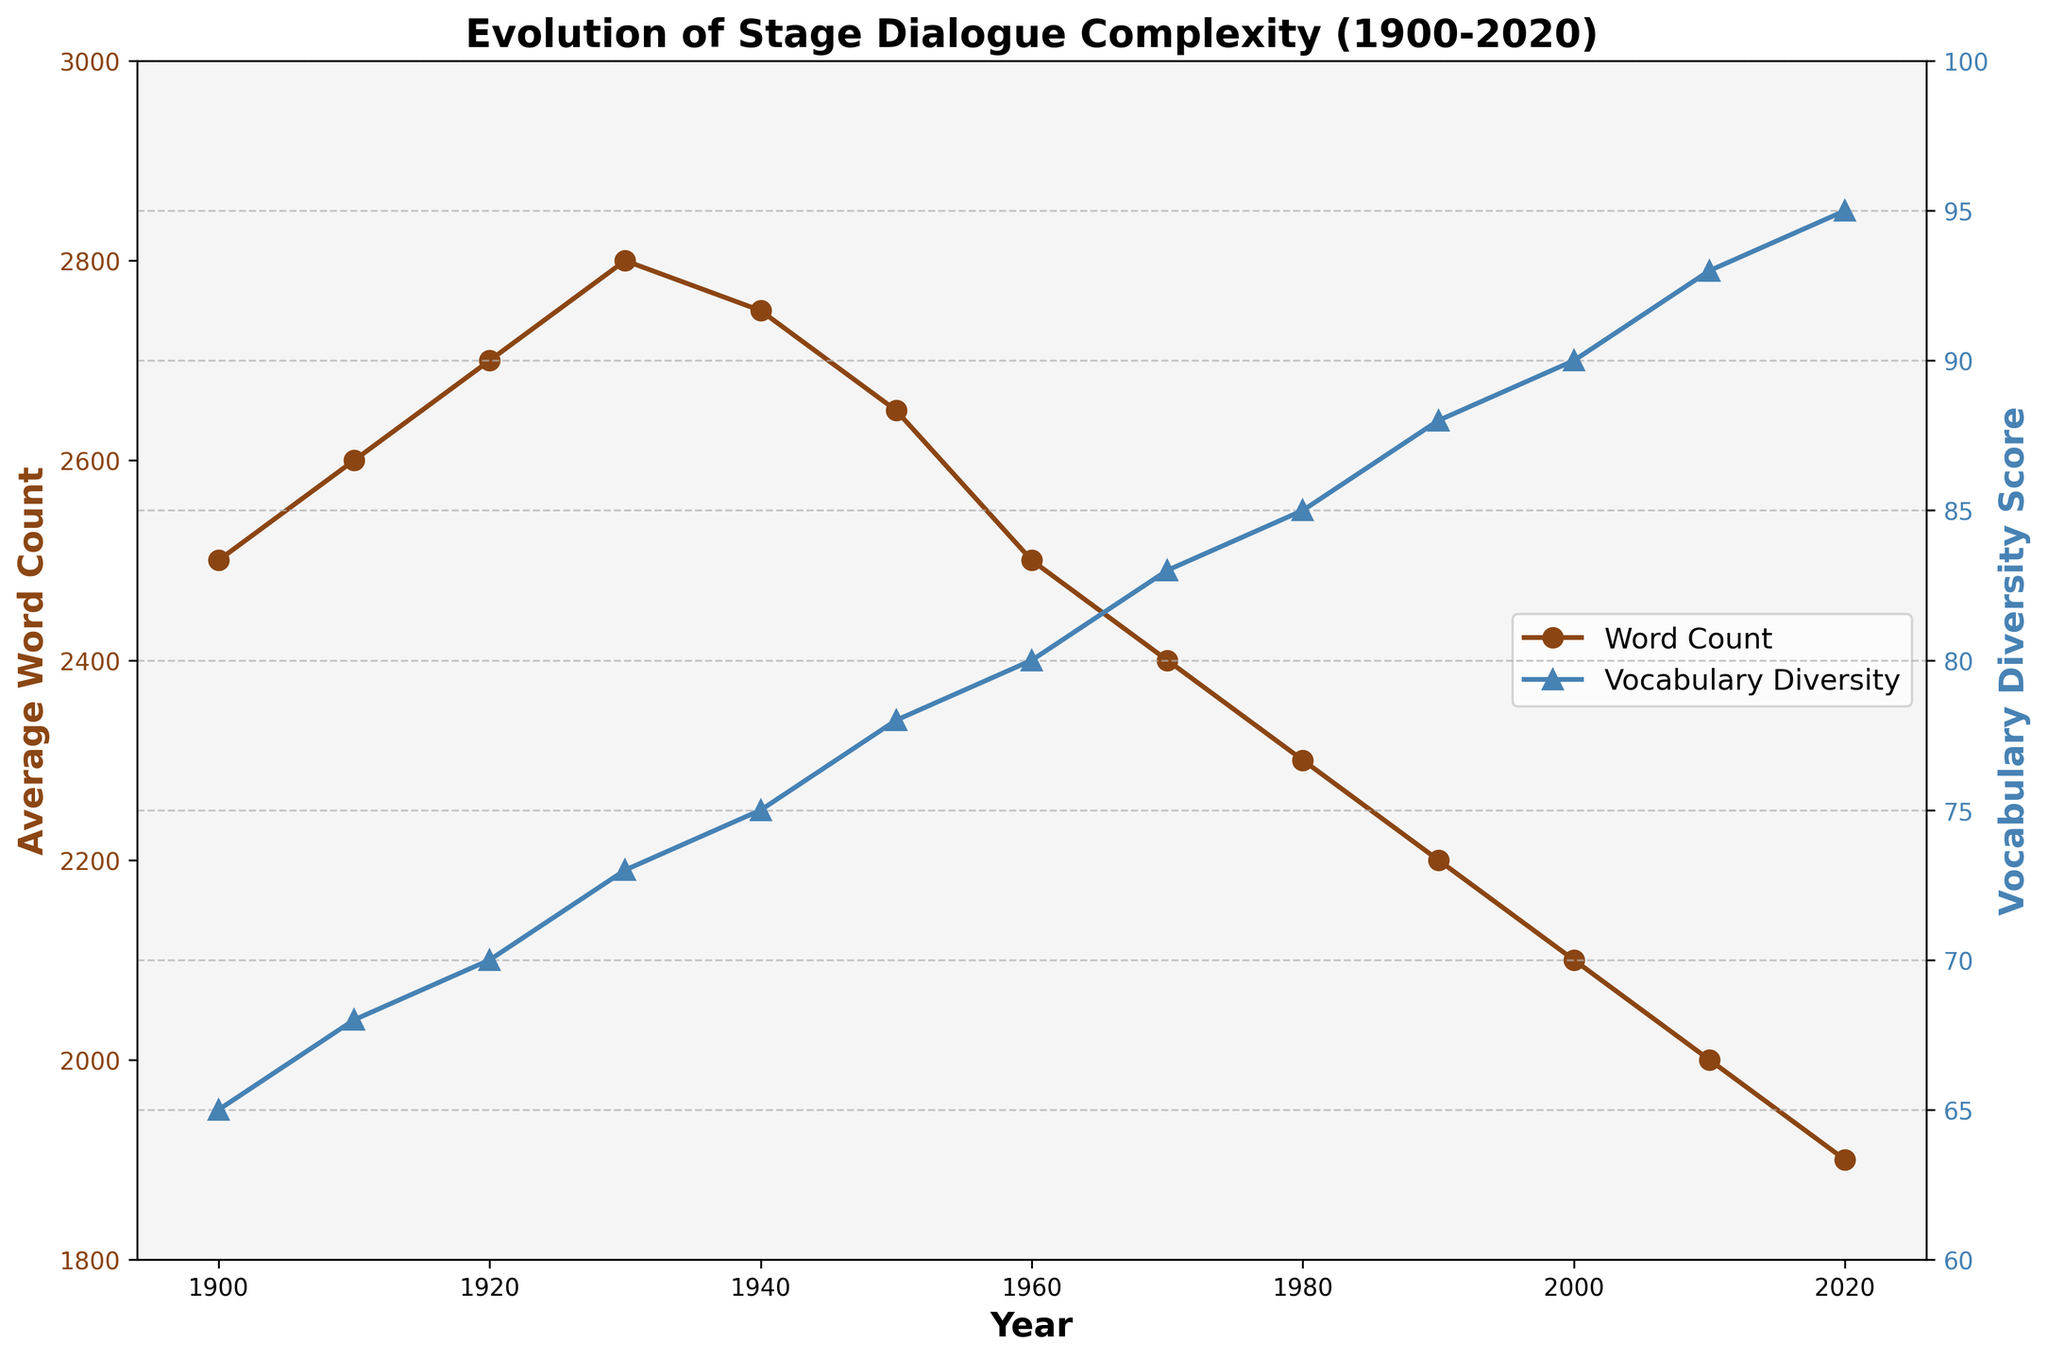What happens to the average word count of plays from 1900 to 2020? The average word count of plays shows a declining trend from 1900 to 2020. Starting at 2500 words in 1900, the count decreases steadily to reach 1900 words by 2020.
Answer: Declines How does vocabulary diversity change over the same period? Vocabulary diversity shows an increasing trend from 1900 to 2020. Starting at a score of 65 in 1900, it steadily rises, reaching a score of 95 by 2020.
Answer: Increases Which year has the highest average word count? By observing the figure, the highest average word count is in the 1930s, with 2800 words.
Answer: 1930 What is the difference in vocabulary diversity scores between 1900 and 2020? Vocabulary diversity scores start at 65 in 1900 and increase to 95 in 2020. The difference is 95 - 65.
Answer: 30 Compare the average word count in 1940 and 1980. Which year has a higher count? In 1940, the average word count is 2750, and in 1980, it is 2300. Since 2750 > 2300, 1940 has a higher word count.
Answer: 1940 What is the trend of the word count from 1910 to 1950? The average word count increases from 2600 in 1910 to 2800 in 1930, then decreases to 2650 by 1950.
Answer: Increases then decreases Does the vocabulary diversity score ever decrease over the years shown? By inspecting the figure closely, the vocabulary diversity score shows a continuous increasing trend, never decreasing.
Answer: No Between 2000 and 2020, how does the average word count change relative to the vocabulary diversity score? From 2000 to 2020, the average word count decreases from 2100 to 1900, while the vocabulary diversity score increases from 90 to 95.
Answer: Word count decreases, diversity increases What is the average of the vocabulary diversity score in the 20th century (from 1900 to 2000)? Calculate the average of the scores from 1900 (65) to 2000 (90): (65 + 68 + 70 + 73 + 75 + 78 + 80 + 83 + 85 + 88 + 90)/11 = 77.72
Answer: 77.72 Which year marks the peak value in vocabulary diversity score? The highest vocabulary diversity score appears in 2020 with a value of 95.
Answer: 2020 